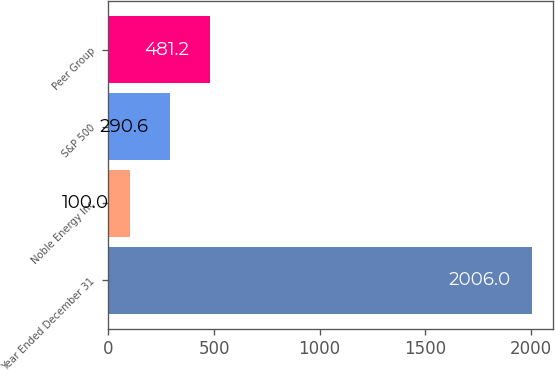<chart> <loc_0><loc_0><loc_500><loc_500><bar_chart><fcel>Year Ended December 31<fcel>Noble Energy Inc<fcel>S&P 500<fcel>Peer Group<nl><fcel>2006<fcel>100<fcel>290.6<fcel>481.2<nl></chart> 